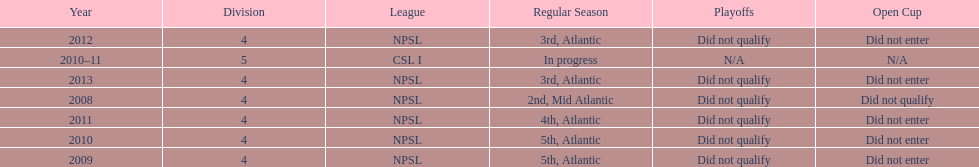In what year only did they compete in division 5 2010-11. Parse the table in full. {'header': ['Year', 'Division', 'League', 'Regular Season', 'Playoffs', 'Open Cup'], 'rows': [['2012', '4', 'NPSL', '3rd, Atlantic', 'Did not qualify', 'Did not enter'], ['2010–11', '5', 'CSL I', 'In progress', 'N/A', 'N/A'], ['2013', '4', 'NPSL', '3rd, Atlantic', 'Did not qualify', 'Did not enter'], ['2008', '4', 'NPSL', '2nd, Mid Atlantic', 'Did not qualify', 'Did not qualify'], ['2011', '4', 'NPSL', '4th, Atlantic', 'Did not qualify', 'Did not enter'], ['2010', '4', 'NPSL', '5th, Atlantic', 'Did not qualify', 'Did not enter'], ['2009', '4', 'NPSL', '5th, Atlantic', 'Did not qualify', 'Did not enter']]} 